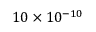<formula> <loc_0><loc_0><loc_500><loc_500>1 0 \times 1 0 ^ { - 1 0 }</formula> 